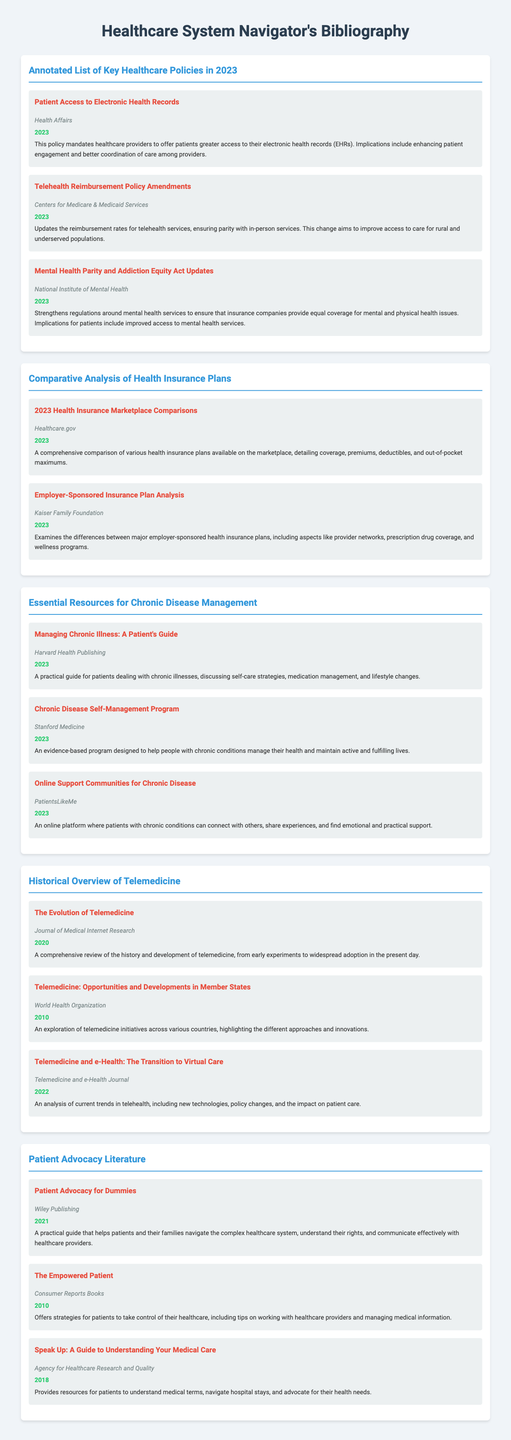What is the first healthcare policy listed? The first healthcare policy mentioned in the document is "Patient Access to Electronic Health Records."
Answer: Patient Access to Electronic Health Records Who published the telehealth reimbursement policy amendments? The telehealth reimbursement policy amendments were published by the "Centers for Medicare & Medicaid Services."
Answer: Centers for Medicare & Medicaid Services In what year was "Managing Chronic Illness: A Patient's Guide" published? The book "Managing Chronic Illness: A Patient's Guide" was published in "2023."
Answer: 2023 What is a significant change included in the Mental Health Parity and Addiction Equity Act updates? A significant change is ensuring that insurance companies provide equal coverage for mental and physical health issues.
Answer: Equal coverage What type of resources does the section on chronic disease management provide? The section provides "books, articles, and online resources" focused on managing chronic diseases.
Answer: Books, articles, and online resources How many telemedicine entries are listed in the Historical Overview section? There are three entries listed in the Historical Overview of Telemedicine section.
Answer: Three What is the title of the guide published by Wiley Publishing? The title of the guide is "Patient Advocacy for Dummies."
Answer: Patient Advocacy for Dummies How does the document describe the purpose of the "Online Support Communities for Chronic Disease"? The document describes that it is a platform for patients to connect with others and find "emotional and practical support."
Answer: Emotional and practical support What are the main aspects compared in the 2023 Health Insurance Marketplace Comparisons? The main aspects compared are coverage, premiums, deductibles, and out-of-pocket maximums.
Answer: Coverage, premiums, deductibles, and out-of-pocket maximums 